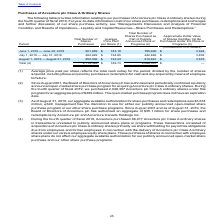According to Accenture Plc's financial document, What is the total number of shares purchased in 2019? According to the financial document, 2,114,324. The relevant text states: "Total (4) 2,114,324 $ 189.73 2,048,307 $ —..." Also, When did Accenture's Board of Directors authorize and confirm an open-market share purchase program for acquiring Accenture pls Class A ordinary shares? According to the financial document, August 2001. The relevant text states: "(2) Since August 2001, the Board of Directors of Accenture plc has authorized and periodically confirmed a publicly annou..." Also, How is average price per share determined? Average price paid per share reflects the total cash outlay for the period, divided by the number of shares acquired, including those acquired by purchase or redemption for cash and any acquired by means of employee forfeiture.. The document states: "_______________ (1) Average price paid per share reflects the total cash outlay for the period, divided by the number of shares acquired, including th..." Also, can you calculate: What is the total number of shares purchased by July 31, 2019? Based on the calculation: 801,659 + 462,629 , the result is 1264288. This is based on the information: "June 1, 2019 — June 30, 2019 801,659 $ 183.18 785,600 $ 3,924 July 1, 2019 — July 31, 2019 462,629 $ 194.65 442,846 $ 3,832..." The key data points involved are: 462,629, 801,659. Also, can you calculate: What is Accenture's average share price paid per share for June and July of 2019? To answer this question, I need to perform calculations using the financial data. The calculation is: (801,659*183.18 + 462,629*194.65)/(801,659+462,629) , which equals 187.38. This is based on the information: "June 1, 2019 — June 30, 2019 801,659 $ 183.18 785,600 $ 3,924 June 1, 2019 — June 30, 2019 801,659 $ 183.18 785,600 $ 3,924 July 1, 2019 — July 31, 2019 462,629 $ 194.65 442,846 $ 3,832 July 1, 2019 —..." The key data points involved are: 183.18, 194.65, 462,629. Also, can you calculate: How much of the shares purchased in July were part of publicly announced plan or programs? Based on the calculation: 442,846/462,629 , the result is 95.72 (percentage). This is based on the information: "July 1, 2019 — July 31, 2019 462,629 $ 194.65 442,846 $ 3,832 July 1, 2019 — July 31, 2019 462,629 $ 194.65 442,846 $ 3,832..." The key data points involved are: 442,846, 462,629. 